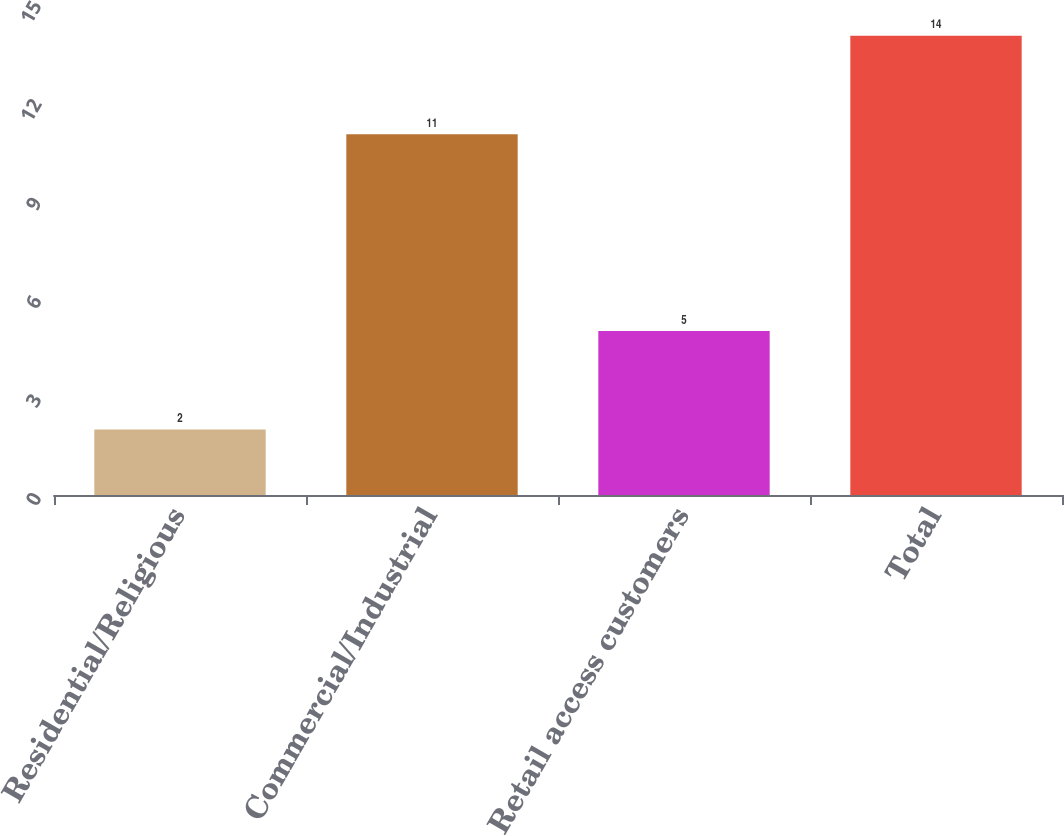<chart> <loc_0><loc_0><loc_500><loc_500><bar_chart><fcel>Residential/Religious<fcel>Commercial/Industrial<fcel>Retail access customers<fcel>Total<nl><fcel>2<fcel>11<fcel>5<fcel>14<nl></chart> 